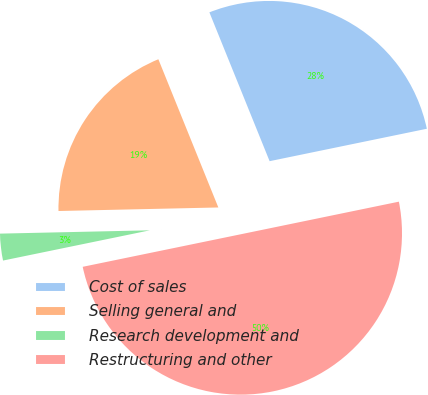Convert chart to OTSL. <chart><loc_0><loc_0><loc_500><loc_500><pie_chart><fcel>Cost of sales<fcel>Selling general and<fcel>Research development and<fcel>Restructuring and other<nl><fcel>27.88%<fcel>19.23%<fcel>2.88%<fcel>50.0%<nl></chart> 